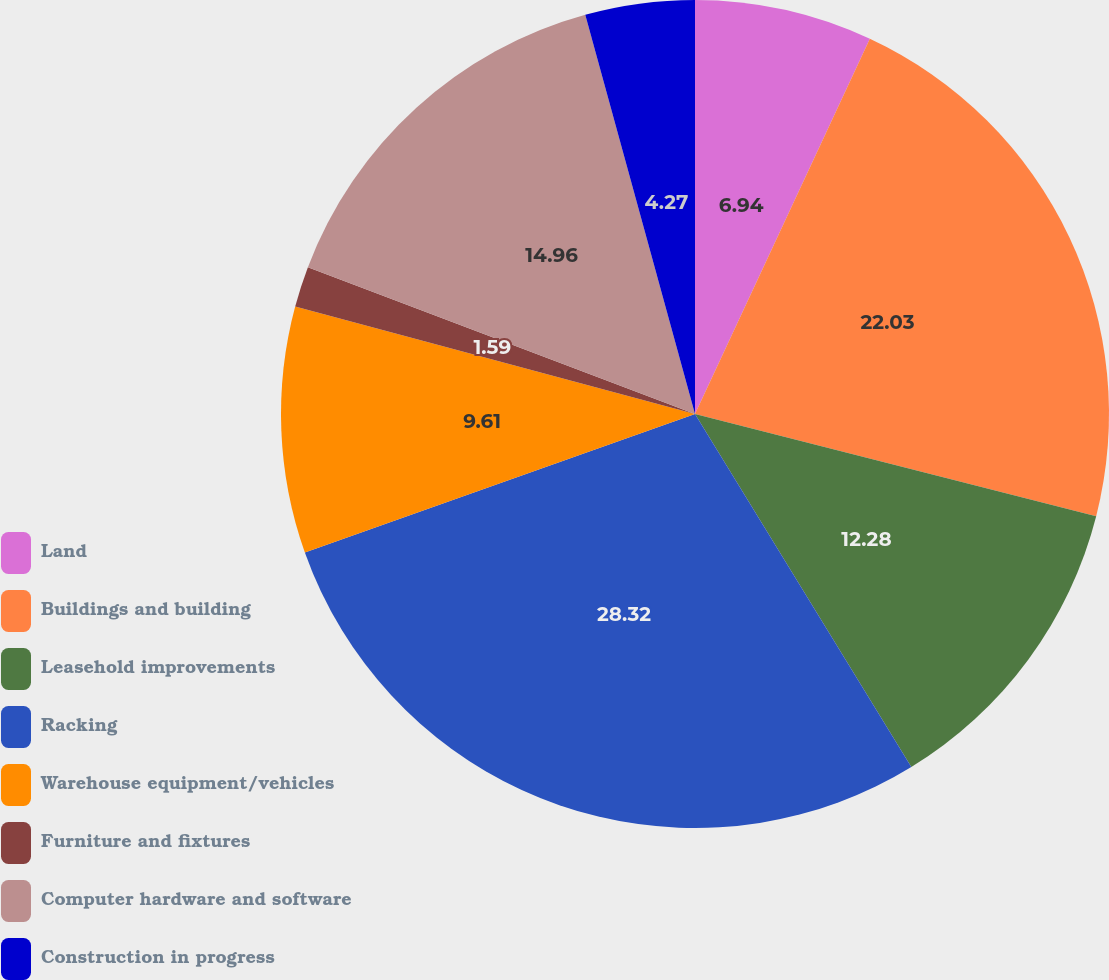Convert chart to OTSL. <chart><loc_0><loc_0><loc_500><loc_500><pie_chart><fcel>Land<fcel>Buildings and building<fcel>Leasehold improvements<fcel>Racking<fcel>Warehouse equipment/vehicles<fcel>Furniture and fixtures<fcel>Computer hardware and software<fcel>Construction in progress<nl><fcel>6.94%<fcel>22.03%<fcel>12.28%<fcel>28.32%<fcel>9.61%<fcel>1.59%<fcel>14.96%<fcel>4.27%<nl></chart> 